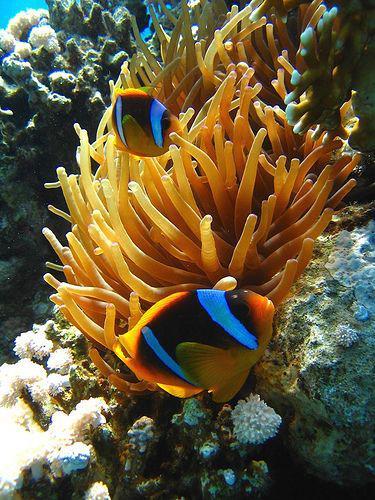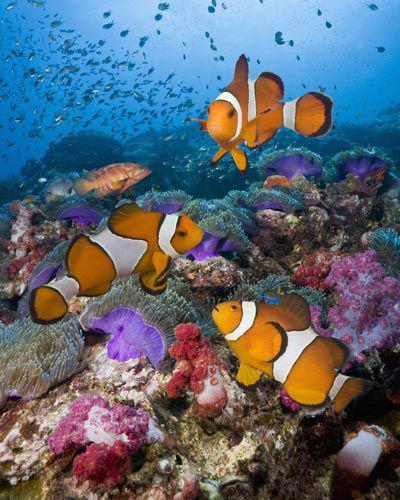The first image is the image on the left, the second image is the image on the right. Given the left and right images, does the statement "There is exactly one clown fish." hold true? Answer yes or no. No. The first image is the image on the left, the second image is the image on the right. Assess this claim about the two images: "Each image shows at least two brightly colored striped fish of the same variety swimming in a scene that contains anemone tendrils.". Correct or not? Answer yes or no. Yes. 